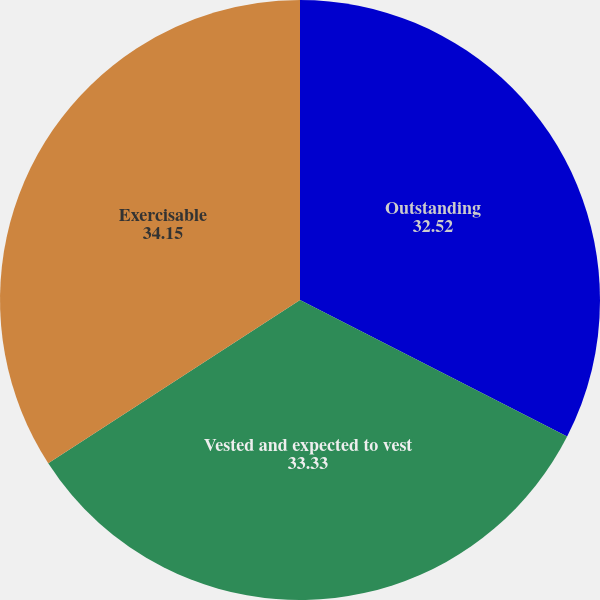<chart> <loc_0><loc_0><loc_500><loc_500><pie_chart><fcel>Outstanding<fcel>Vested and expected to vest<fcel>Exercisable<nl><fcel>32.52%<fcel>33.33%<fcel>34.15%<nl></chart> 